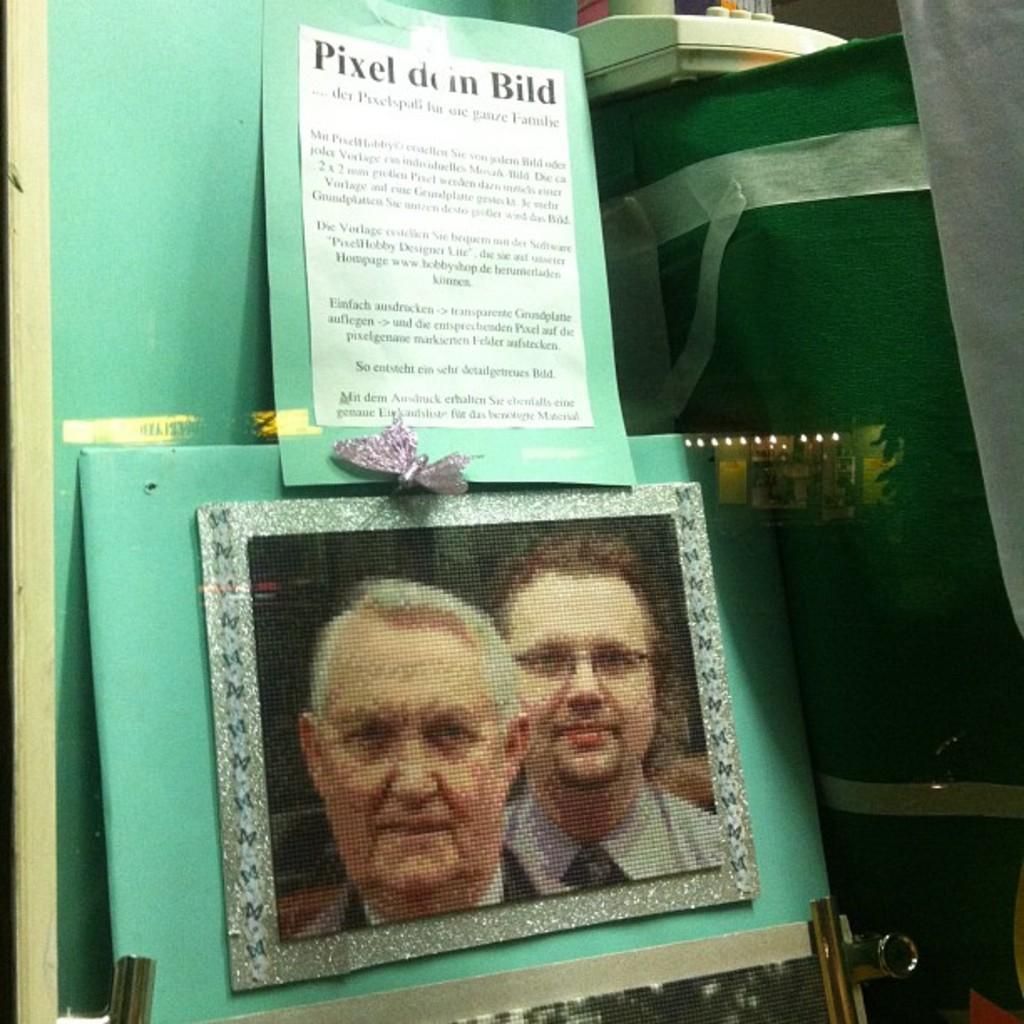Please provide a concise description of this image. In this image we can see the photo frame, bag, board, cloth, paper and the white color object. 